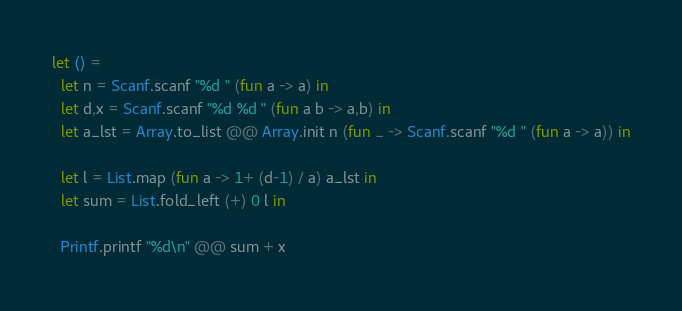Convert code to text. <code><loc_0><loc_0><loc_500><loc_500><_OCaml_>let () =
  let n = Scanf.scanf "%d " (fun a -> a) in
  let d,x = Scanf.scanf "%d %d " (fun a b -> a,b) in
  let a_lst = Array.to_list @@ Array.init n (fun _ -> Scanf.scanf "%d " (fun a -> a)) in

  let l = List.map (fun a -> 1+ (d-1) / a) a_lst in
  let sum = List.fold_left (+) 0 l in

  Printf.printf "%d\n" @@ sum + x
</code> 